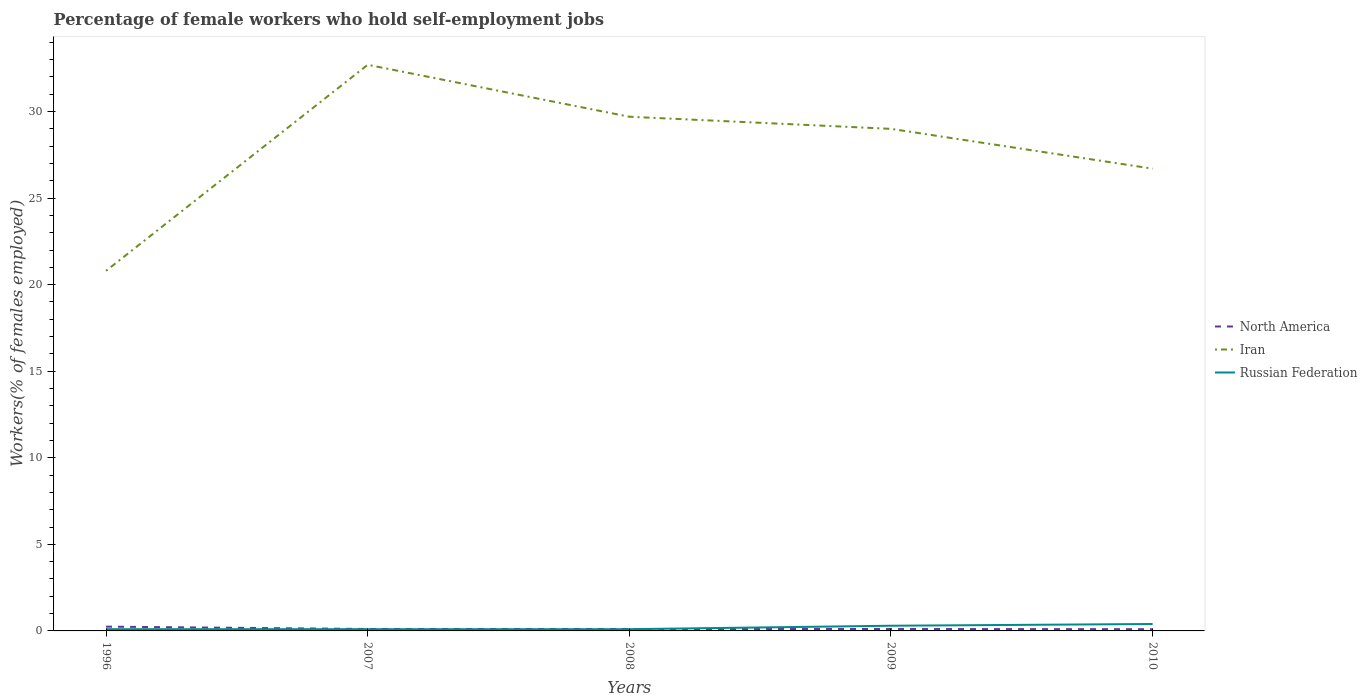How many different coloured lines are there?
Offer a very short reply. 3. Does the line corresponding to North America intersect with the line corresponding to Russian Federation?
Your answer should be compact. Yes. Across all years, what is the maximum percentage of self-employed female workers in Russian Federation?
Offer a very short reply. 0.1. What is the total percentage of self-employed female workers in Russian Federation in the graph?
Provide a succinct answer. -0.1. What is the difference between the highest and the second highest percentage of self-employed female workers in North America?
Offer a very short reply. 0.15. What is the difference between the highest and the lowest percentage of self-employed female workers in Iran?
Offer a terse response. 3. How many years are there in the graph?
Your response must be concise. 5. Are the values on the major ticks of Y-axis written in scientific E-notation?
Give a very brief answer. No. Does the graph contain any zero values?
Provide a short and direct response. No. What is the title of the graph?
Provide a short and direct response. Percentage of female workers who hold self-employment jobs. What is the label or title of the X-axis?
Provide a short and direct response. Years. What is the label or title of the Y-axis?
Provide a succinct answer. Workers(% of females employed). What is the Workers(% of females employed) of North America in 1996?
Your answer should be very brief. 0.25. What is the Workers(% of females employed) in Iran in 1996?
Make the answer very short. 20.8. What is the Workers(% of females employed) in Russian Federation in 1996?
Make the answer very short. 0.1. What is the Workers(% of females employed) in North America in 2007?
Offer a very short reply. 0.11. What is the Workers(% of females employed) in Iran in 2007?
Ensure brevity in your answer.  32.7. What is the Workers(% of females employed) of Russian Federation in 2007?
Your answer should be compact. 0.1. What is the Workers(% of females employed) in North America in 2008?
Your answer should be compact. 0.11. What is the Workers(% of females employed) of Iran in 2008?
Make the answer very short. 29.7. What is the Workers(% of females employed) of Russian Federation in 2008?
Keep it short and to the point. 0.1. What is the Workers(% of females employed) in North America in 2009?
Your answer should be very brief. 0.11. What is the Workers(% of females employed) in Iran in 2009?
Provide a short and direct response. 29. What is the Workers(% of females employed) of Russian Federation in 2009?
Offer a very short reply. 0.3. What is the Workers(% of females employed) of North America in 2010?
Ensure brevity in your answer.  0.1. What is the Workers(% of females employed) of Iran in 2010?
Make the answer very short. 26.7. What is the Workers(% of females employed) in Russian Federation in 2010?
Your answer should be very brief. 0.4. Across all years, what is the maximum Workers(% of females employed) in North America?
Your response must be concise. 0.25. Across all years, what is the maximum Workers(% of females employed) in Iran?
Give a very brief answer. 32.7. Across all years, what is the maximum Workers(% of females employed) in Russian Federation?
Offer a terse response. 0.4. Across all years, what is the minimum Workers(% of females employed) in North America?
Keep it short and to the point. 0.1. Across all years, what is the minimum Workers(% of females employed) in Iran?
Your response must be concise. 20.8. Across all years, what is the minimum Workers(% of females employed) of Russian Federation?
Give a very brief answer. 0.1. What is the total Workers(% of females employed) in North America in the graph?
Ensure brevity in your answer.  0.68. What is the total Workers(% of females employed) of Iran in the graph?
Your answer should be very brief. 138.9. What is the difference between the Workers(% of females employed) of North America in 1996 and that in 2007?
Ensure brevity in your answer.  0.14. What is the difference between the Workers(% of females employed) of North America in 1996 and that in 2008?
Keep it short and to the point. 0.14. What is the difference between the Workers(% of females employed) of Russian Federation in 1996 and that in 2008?
Offer a terse response. 0. What is the difference between the Workers(% of females employed) in North America in 1996 and that in 2009?
Give a very brief answer. 0.14. What is the difference between the Workers(% of females employed) of Iran in 1996 and that in 2009?
Your answer should be compact. -8.2. What is the difference between the Workers(% of females employed) of North America in 1996 and that in 2010?
Offer a very short reply. 0.15. What is the difference between the Workers(% of females employed) of Russian Federation in 1996 and that in 2010?
Provide a succinct answer. -0.3. What is the difference between the Workers(% of females employed) of North America in 2007 and that in 2008?
Make the answer very short. -0. What is the difference between the Workers(% of females employed) of Iran in 2007 and that in 2008?
Provide a short and direct response. 3. What is the difference between the Workers(% of females employed) in Russian Federation in 2007 and that in 2008?
Make the answer very short. 0. What is the difference between the Workers(% of females employed) in North America in 2007 and that in 2009?
Make the answer very short. -0. What is the difference between the Workers(% of females employed) of Iran in 2007 and that in 2009?
Make the answer very short. 3.7. What is the difference between the Workers(% of females employed) of Russian Federation in 2007 and that in 2009?
Your answer should be compact. -0.2. What is the difference between the Workers(% of females employed) of North America in 2007 and that in 2010?
Keep it short and to the point. 0.01. What is the difference between the Workers(% of females employed) in Iran in 2007 and that in 2010?
Your answer should be compact. 6. What is the difference between the Workers(% of females employed) in North America in 2008 and that in 2009?
Make the answer very short. -0. What is the difference between the Workers(% of females employed) of Iran in 2008 and that in 2009?
Your response must be concise. 0.7. What is the difference between the Workers(% of females employed) in North America in 2008 and that in 2010?
Your answer should be compact. 0.01. What is the difference between the Workers(% of females employed) of North America in 2009 and that in 2010?
Provide a short and direct response. 0.01. What is the difference between the Workers(% of females employed) in Iran in 2009 and that in 2010?
Keep it short and to the point. 2.3. What is the difference between the Workers(% of females employed) of North America in 1996 and the Workers(% of females employed) of Iran in 2007?
Your response must be concise. -32.45. What is the difference between the Workers(% of females employed) of North America in 1996 and the Workers(% of females employed) of Russian Federation in 2007?
Keep it short and to the point. 0.15. What is the difference between the Workers(% of females employed) in Iran in 1996 and the Workers(% of females employed) in Russian Federation in 2007?
Provide a succinct answer. 20.7. What is the difference between the Workers(% of females employed) in North America in 1996 and the Workers(% of females employed) in Iran in 2008?
Your response must be concise. -29.45. What is the difference between the Workers(% of females employed) in North America in 1996 and the Workers(% of females employed) in Russian Federation in 2008?
Give a very brief answer. 0.15. What is the difference between the Workers(% of females employed) in Iran in 1996 and the Workers(% of females employed) in Russian Federation in 2008?
Keep it short and to the point. 20.7. What is the difference between the Workers(% of females employed) of North America in 1996 and the Workers(% of females employed) of Iran in 2009?
Provide a succinct answer. -28.75. What is the difference between the Workers(% of females employed) of North America in 1996 and the Workers(% of females employed) of Russian Federation in 2009?
Your answer should be compact. -0.05. What is the difference between the Workers(% of females employed) in Iran in 1996 and the Workers(% of females employed) in Russian Federation in 2009?
Offer a very short reply. 20.5. What is the difference between the Workers(% of females employed) in North America in 1996 and the Workers(% of females employed) in Iran in 2010?
Make the answer very short. -26.45. What is the difference between the Workers(% of females employed) of North America in 1996 and the Workers(% of females employed) of Russian Federation in 2010?
Give a very brief answer. -0.15. What is the difference between the Workers(% of females employed) in Iran in 1996 and the Workers(% of females employed) in Russian Federation in 2010?
Offer a very short reply. 20.4. What is the difference between the Workers(% of females employed) of North America in 2007 and the Workers(% of females employed) of Iran in 2008?
Your answer should be very brief. -29.59. What is the difference between the Workers(% of females employed) in North America in 2007 and the Workers(% of females employed) in Russian Federation in 2008?
Provide a short and direct response. 0.01. What is the difference between the Workers(% of females employed) in Iran in 2007 and the Workers(% of females employed) in Russian Federation in 2008?
Make the answer very short. 32.6. What is the difference between the Workers(% of females employed) in North America in 2007 and the Workers(% of females employed) in Iran in 2009?
Make the answer very short. -28.89. What is the difference between the Workers(% of females employed) in North America in 2007 and the Workers(% of females employed) in Russian Federation in 2009?
Provide a short and direct response. -0.19. What is the difference between the Workers(% of females employed) of Iran in 2007 and the Workers(% of females employed) of Russian Federation in 2009?
Make the answer very short. 32.4. What is the difference between the Workers(% of females employed) of North America in 2007 and the Workers(% of females employed) of Iran in 2010?
Ensure brevity in your answer.  -26.59. What is the difference between the Workers(% of females employed) in North America in 2007 and the Workers(% of females employed) in Russian Federation in 2010?
Give a very brief answer. -0.29. What is the difference between the Workers(% of females employed) of Iran in 2007 and the Workers(% of females employed) of Russian Federation in 2010?
Your answer should be compact. 32.3. What is the difference between the Workers(% of females employed) of North America in 2008 and the Workers(% of females employed) of Iran in 2009?
Your answer should be compact. -28.89. What is the difference between the Workers(% of females employed) of North America in 2008 and the Workers(% of females employed) of Russian Federation in 2009?
Keep it short and to the point. -0.19. What is the difference between the Workers(% of females employed) of Iran in 2008 and the Workers(% of females employed) of Russian Federation in 2009?
Offer a very short reply. 29.4. What is the difference between the Workers(% of females employed) of North America in 2008 and the Workers(% of females employed) of Iran in 2010?
Keep it short and to the point. -26.59. What is the difference between the Workers(% of females employed) in North America in 2008 and the Workers(% of females employed) in Russian Federation in 2010?
Ensure brevity in your answer.  -0.29. What is the difference between the Workers(% of females employed) in Iran in 2008 and the Workers(% of females employed) in Russian Federation in 2010?
Offer a terse response. 29.3. What is the difference between the Workers(% of females employed) of North America in 2009 and the Workers(% of females employed) of Iran in 2010?
Your answer should be compact. -26.59. What is the difference between the Workers(% of females employed) in North America in 2009 and the Workers(% of females employed) in Russian Federation in 2010?
Offer a terse response. -0.29. What is the difference between the Workers(% of females employed) of Iran in 2009 and the Workers(% of females employed) of Russian Federation in 2010?
Keep it short and to the point. 28.6. What is the average Workers(% of females employed) of North America per year?
Give a very brief answer. 0.14. What is the average Workers(% of females employed) in Iran per year?
Give a very brief answer. 27.78. In the year 1996, what is the difference between the Workers(% of females employed) in North America and Workers(% of females employed) in Iran?
Offer a very short reply. -20.55. In the year 1996, what is the difference between the Workers(% of females employed) of North America and Workers(% of females employed) of Russian Federation?
Ensure brevity in your answer.  0.15. In the year 1996, what is the difference between the Workers(% of females employed) in Iran and Workers(% of females employed) in Russian Federation?
Offer a very short reply. 20.7. In the year 2007, what is the difference between the Workers(% of females employed) in North America and Workers(% of females employed) in Iran?
Keep it short and to the point. -32.59. In the year 2007, what is the difference between the Workers(% of females employed) in North America and Workers(% of females employed) in Russian Federation?
Your response must be concise. 0.01. In the year 2007, what is the difference between the Workers(% of females employed) of Iran and Workers(% of females employed) of Russian Federation?
Ensure brevity in your answer.  32.6. In the year 2008, what is the difference between the Workers(% of females employed) in North America and Workers(% of females employed) in Iran?
Your answer should be very brief. -29.59. In the year 2008, what is the difference between the Workers(% of females employed) in North America and Workers(% of females employed) in Russian Federation?
Offer a terse response. 0.01. In the year 2008, what is the difference between the Workers(% of females employed) of Iran and Workers(% of females employed) of Russian Federation?
Your answer should be very brief. 29.6. In the year 2009, what is the difference between the Workers(% of females employed) in North America and Workers(% of females employed) in Iran?
Provide a succinct answer. -28.89. In the year 2009, what is the difference between the Workers(% of females employed) of North America and Workers(% of females employed) of Russian Federation?
Make the answer very short. -0.19. In the year 2009, what is the difference between the Workers(% of females employed) of Iran and Workers(% of females employed) of Russian Federation?
Give a very brief answer. 28.7. In the year 2010, what is the difference between the Workers(% of females employed) in North America and Workers(% of females employed) in Iran?
Your answer should be very brief. -26.6. In the year 2010, what is the difference between the Workers(% of females employed) in Iran and Workers(% of females employed) in Russian Federation?
Your answer should be very brief. 26.3. What is the ratio of the Workers(% of females employed) in North America in 1996 to that in 2007?
Make the answer very short. 2.24. What is the ratio of the Workers(% of females employed) of Iran in 1996 to that in 2007?
Your answer should be very brief. 0.64. What is the ratio of the Workers(% of females employed) of Russian Federation in 1996 to that in 2007?
Provide a short and direct response. 1. What is the ratio of the Workers(% of females employed) of North America in 1996 to that in 2008?
Your answer should be compact. 2.23. What is the ratio of the Workers(% of females employed) in Iran in 1996 to that in 2008?
Give a very brief answer. 0.7. What is the ratio of the Workers(% of females employed) of North America in 1996 to that in 2009?
Offer a very short reply. 2.23. What is the ratio of the Workers(% of females employed) of Iran in 1996 to that in 2009?
Provide a short and direct response. 0.72. What is the ratio of the Workers(% of females employed) in North America in 1996 to that in 2010?
Your answer should be compact. 2.47. What is the ratio of the Workers(% of females employed) in Iran in 1996 to that in 2010?
Offer a terse response. 0.78. What is the ratio of the Workers(% of females employed) in Russian Federation in 1996 to that in 2010?
Make the answer very short. 0.25. What is the ratio of the Workers(% of females employed) of North America in 2007 to that in 2008?
Make the answer very short. 1. What is the ratio of the Workers(% of females employed) of Iran in 2007 to that in 2008?
Your response must be concise. 1.1. What is the ratio of the Workers(% of females employed) in North America in 2007 to that in 2009?
Your answer should be very brief. 1. What is the ratio of the Workers(% of females employed) in Iran in 2007 to that in 2009?
Offer a terse response. 1.13. What is the ratio of the Workers(% of females employed) of North America in 2007 to that in 2010?
Your answer should be compact. 1.11. What is the ratio of the Workers(% of females employed) in Iran in 2007 to that in 2010?
Your answer should be compact. 1.22. What is the ratio of the Workers(% of females employed) of Russian Federation in 2007 to that in 2010?
Give a very brief answer. 0.25. What is the ratio of the Workers(% of females employed) of Iran in 2008 to that in 2009?
Offer a terse response. 1.02. What is the ratio of the Workers(% of females employed) of Russian Federation in 2008 to that in 2009?
Your response must be concise. 0.33. What is the ratio of the Workers(% of females employed) of North America in 2008 to that in 2010?
Offer a very short reply. 1.11. What is the ratio of the Workers(% of females employed) of Iran in 2008 to that in 2010?
Provide a short and direct response. 1.11. What is the ratio of the Workers(% of females employed) of Russian Federation in 2008 to that in 2010?
Your answer should be very brief. 0.25. What is the ratio of the Workers(% of females employed) of North America in 2009 to that in 2010?
Offer a terse response. 1.11. What is the ratio of the Workers(% of females employed) of Iran in 2009 to that in 2010?
Keep it short and to the point. 1.09. What is the difference between the highest and the second highest Workers(% of females employed) of North America?
Your answer should be compact. 0.14. What is the difference between the highest and the second highest Workers(% of females employed) of Iran?
Offer a terse response. 3. What is the difference between the highest and the second highest Workers(% of females employed) in Russian Federation?
Offer a terse response. 0.1. What is the difference between the highest and the lowest Workers(% of females employed) of North America?
Ensure brevity in your answer.  0.15. What is the difference between the highest and the lowest Workers(% of females employed) of Russian Federation?
Your response must be concise. 0.3. 